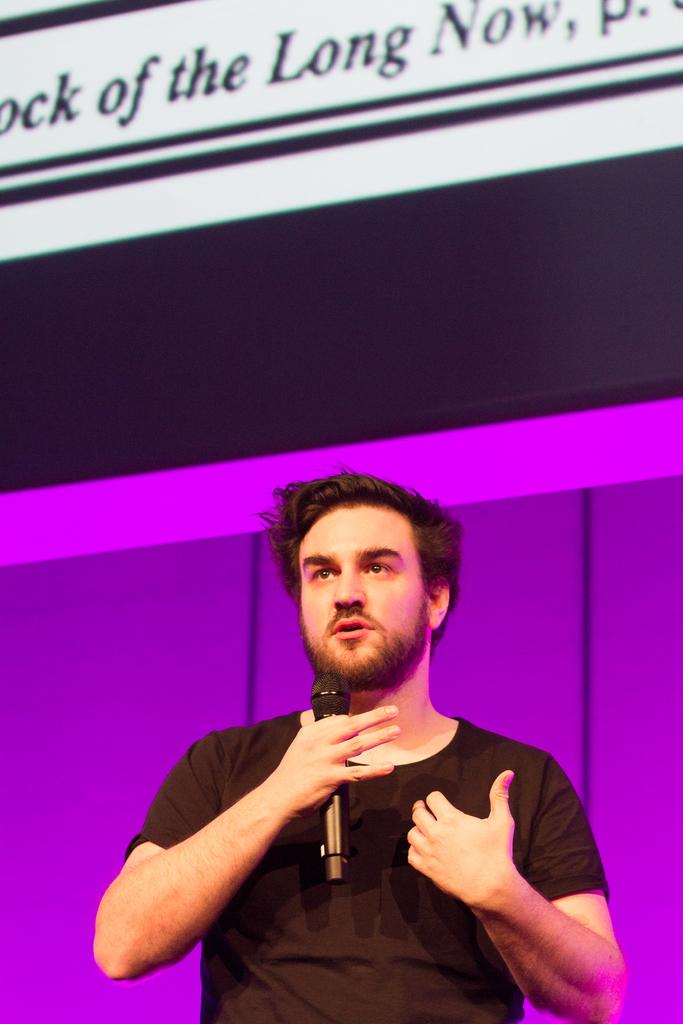What is the main subject of the image? The main subject of the image is a man. What is the man holding in his hand? The man is holding a microphone in his hand. What type of coil is present in the image? There is no coil present in the image. Can you see a church in the background of the image? There is no church visible in the image; it only features a man holding a microphone. 